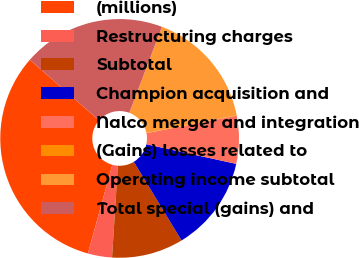<chart> <loc_0><loc_0><loc_500><loc_500><pie_chart><fcel>(millions)<fcel>Restructuring charges<fcel>Subtotal<fcel>Champion acquisition and<fcel>Nalco merger and integration<fcel>(Gains) losses related to<fcel>Operating income subtotal<fcel>Total special (gains) and<nl><fcel>32.17%<fcel>3.27%<fcel>9.69%<fcel>12.9%<fcel>6.48%<fcel>0.06%<fcel>16.11%<fcel>19.32%<nl></chart> 